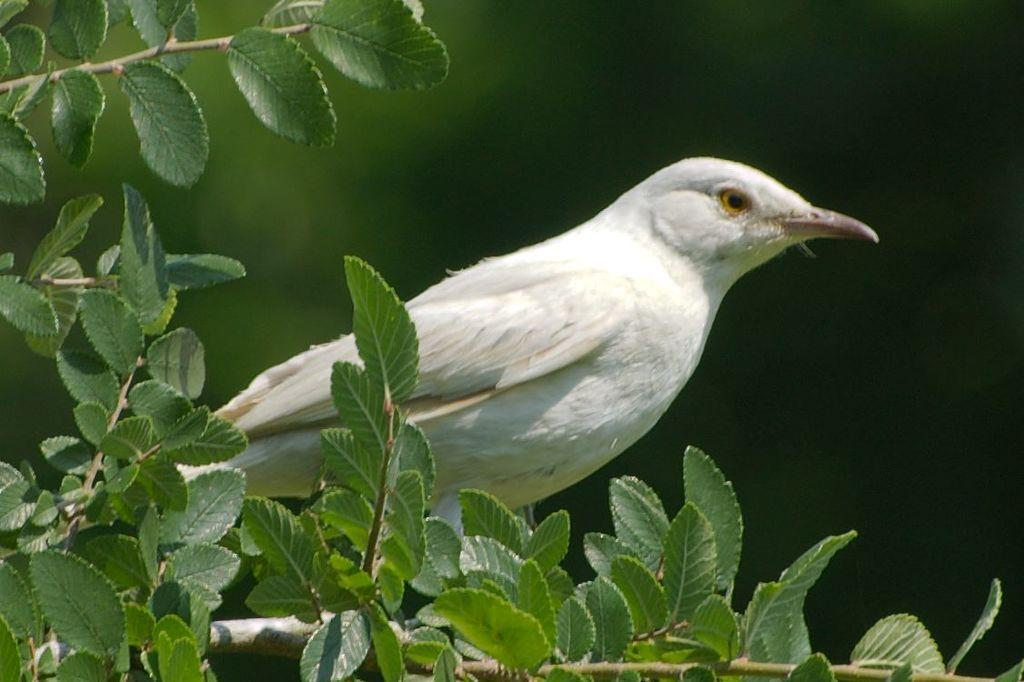What color are the leaves in the image? The leaves in the image are green. Can you describe the white object in the image? There is a white color object sitting on the plant. What type of cast can be seen on the tongue of the plant in the image? There is no cast or tongue present in the image; it features green leaves and a white object sitting on a plant. 